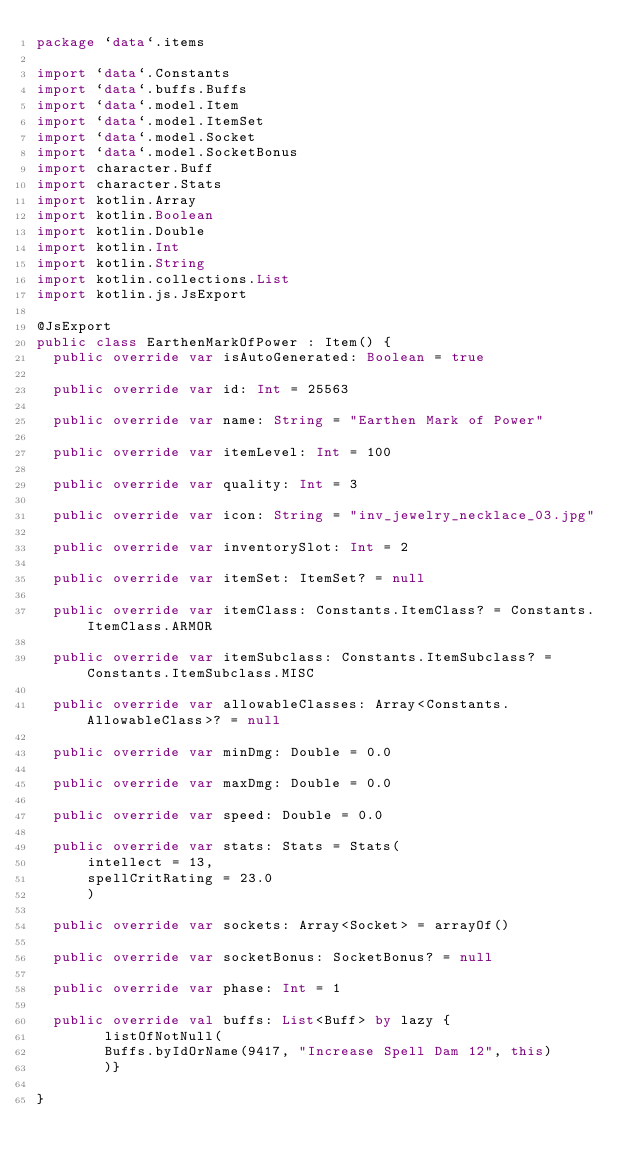Convert code to text. <code><loc_0><loc_0><loc_500><loc_500><_Kotlin_>package `data`.items

import `data`.Constants
import `data`.buffs.Buffs
import `data`.model.Item
import `data`.model.ItemSet
import `data`.model.Socket
import `data`.model.SocketBonus
import character.Buff
import character.Stats
import kotlin.Array
import kotlin.Boolean
import kotlin.Double
import kotlin.Int
import kotlin.String
import kotlin.collections.List
import kotlin.js.JsExport

@JsExport
public class EarthenMarkOfPower : Item() {
  public override var isAutoGenerated: Boolean = true

  public override var id: Int = 25563

  public override var name: String = "Earthen Mark of Power"

  public override var itemLevel: Int = 100

  public override var quality: Int = 3

  public override var icon: String = "inv_jewelry_necklace_03.jpg"

  public override var inventorySlot: Int = 2

  public override var itemSet: ItemSet? = null

  public override var itemClass: Constants.ItemClass? = Constants.ItemClass.ARMOR

  public override var itemSubclass: Constants.ItemSubclass? = Constants.ItemSubclass.MISC

  public override var allowableClasses: Array<Constants.AllowableClass>? = null

  public override var minDmg: Double = 0.0

  public override var maxDmg: Double = 0.0

  public override var speed: Double = 0.0

  public override var stats: Stats = Stats(
      intellect = 13,
      spellCritRating = 23.0
      )

  public override var sockets: Array<Socket> = arrayOf()

  public override var socketBonus: SocketBonus? = null

  public override var phase: Int = 1

  public override val buffs: List<Buff> by lazy {
        listOfNotNull(
        Buffs.byIdOrName(9417, "Increase Spell Dam 12", this)
        )}

}
</code> 